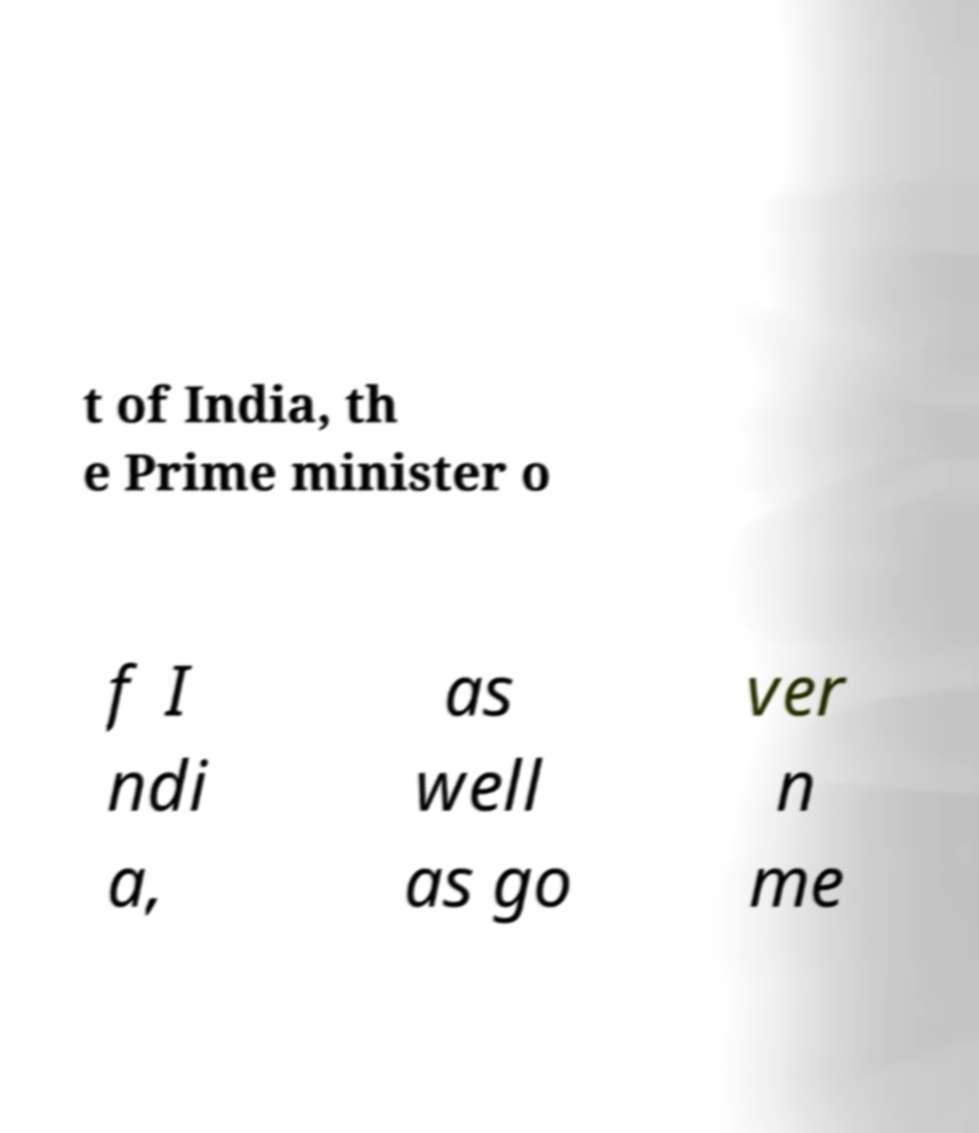What messages or text are displayed in this image? I need them in a readable, typed format. t of India, th e Prime minister o f I ndi a, as well as go ver n me 